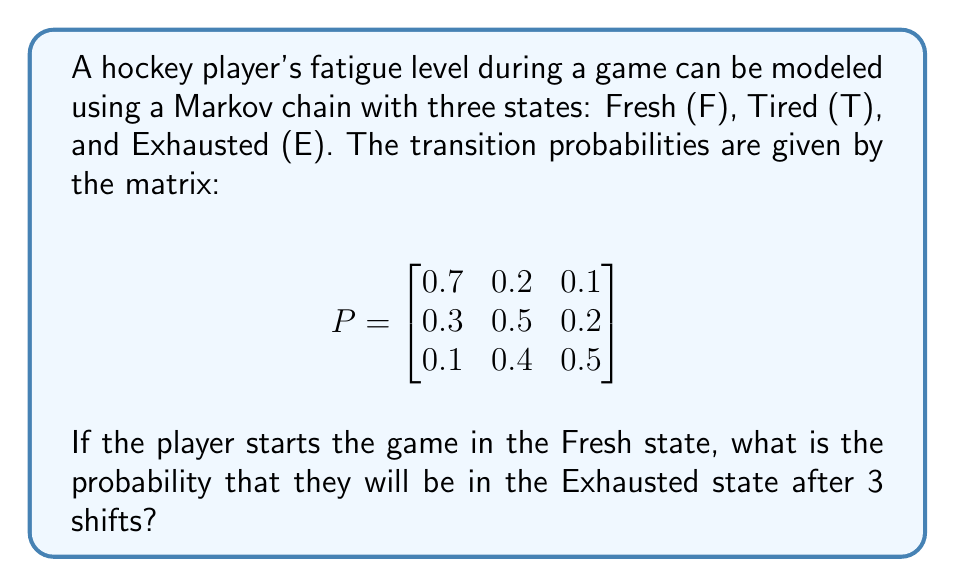Give your solution to this math problem. To solve this problem, we need to use the Chapman-Kolmogorov equations and matrix multiplication. Let's follow these steps:

1) The initial state vector is $\pi_0 = [1, 0, 0]$ since the player starts in the Fresh state.

2) We need to calculate $\pi_0 P^3$, where $P^3$ is the transition matrix raised to the power of 3.

3) Let's calculate $P^2$ first:

   $$P^2 = P \cdot P = \begin{bmatrix}
   0.58 & 0.28 & 0.14 \\
   0.41 & 0.39 & 0.20 \\
   0.26 & 0.41 & 0.33
   \end{bmatrix}$$

4) Now let's calculate $P^3$:

   $$P^3 = P^2 \cdot P = \begin{bmatrix}
   0.523 & 0.314 & 0.163 \\
   0.439 & 0.356 & 0.205 \\
   0.353 & 0.387 & 0.260
   \end{bmatrix}$$

5) Finally, we multiply $\pi_0$ by $P^3$:

   $$\pi_0 P^3 = [1, 0, 0] \cdot \begin{bmatrix}
   0.523 & 0.314 & 0.163 \\
   0.439 & 0.356 & 0.205 \\
   0.353 & 0.387 & 0.260
   \end{bmatrix} = [0.523, 0.314, 0.163]$$

6) The probability of being in the Exhausted state after 3 shifts is the third element of this resulting vector.
Answer: 0.163 